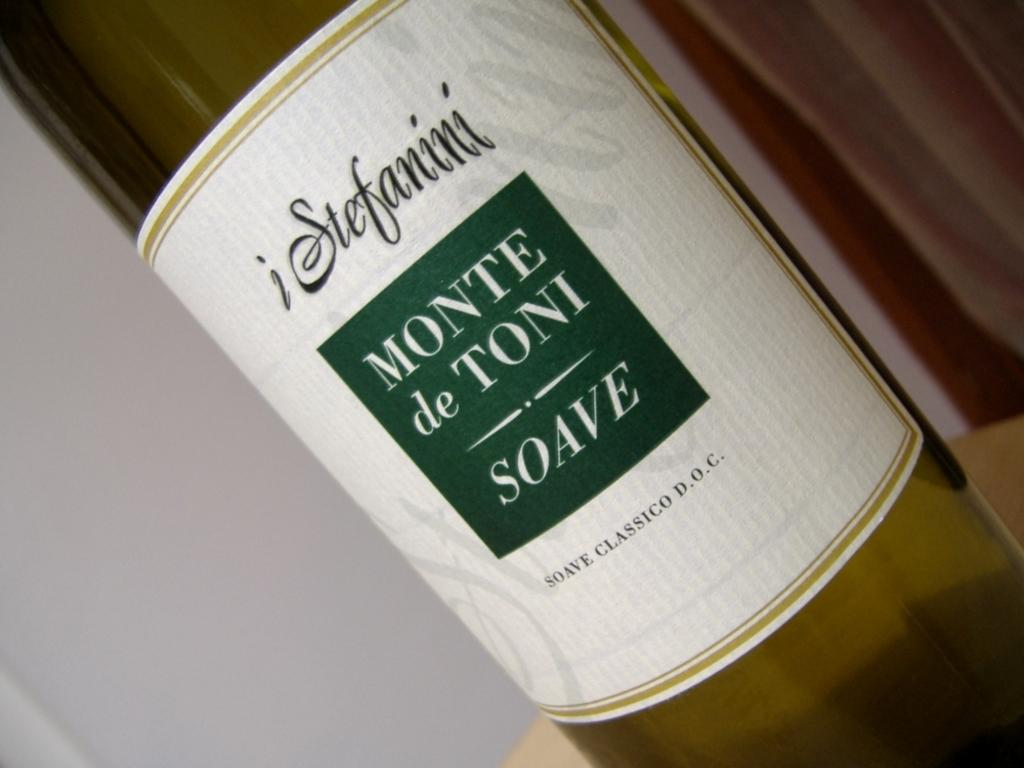<image>
Render a clear and concise summary of the photo. iStefanini Monte de Toni Soave Classic Wine, D.O.C. 